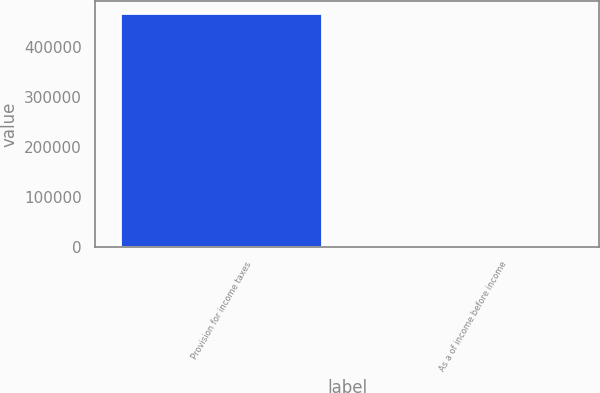Convert chart. <chart><loc_0><loc_0><loc_500><loc_500><bar_chart><fcel>Provision for income taxes<fcel>As a of income before income<nl><fcel>467285<fcel>30<nl></chart> 